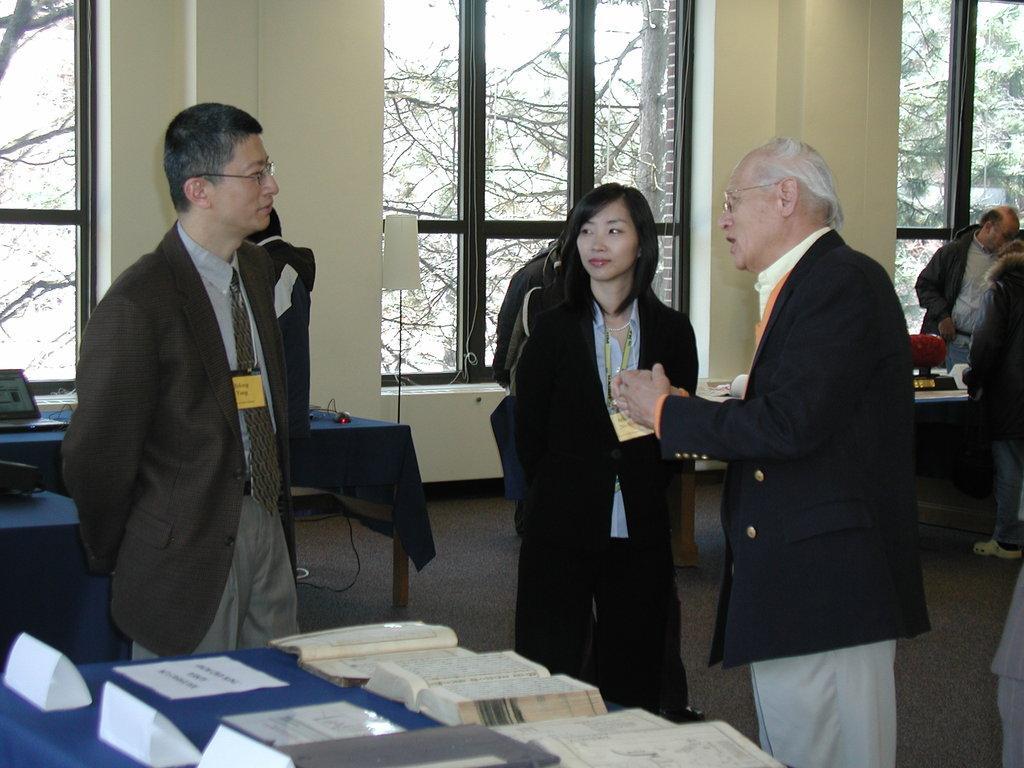Can you describe this image briefly? there are three persons are standing near the table two men and one woman through the window we can see trees. 